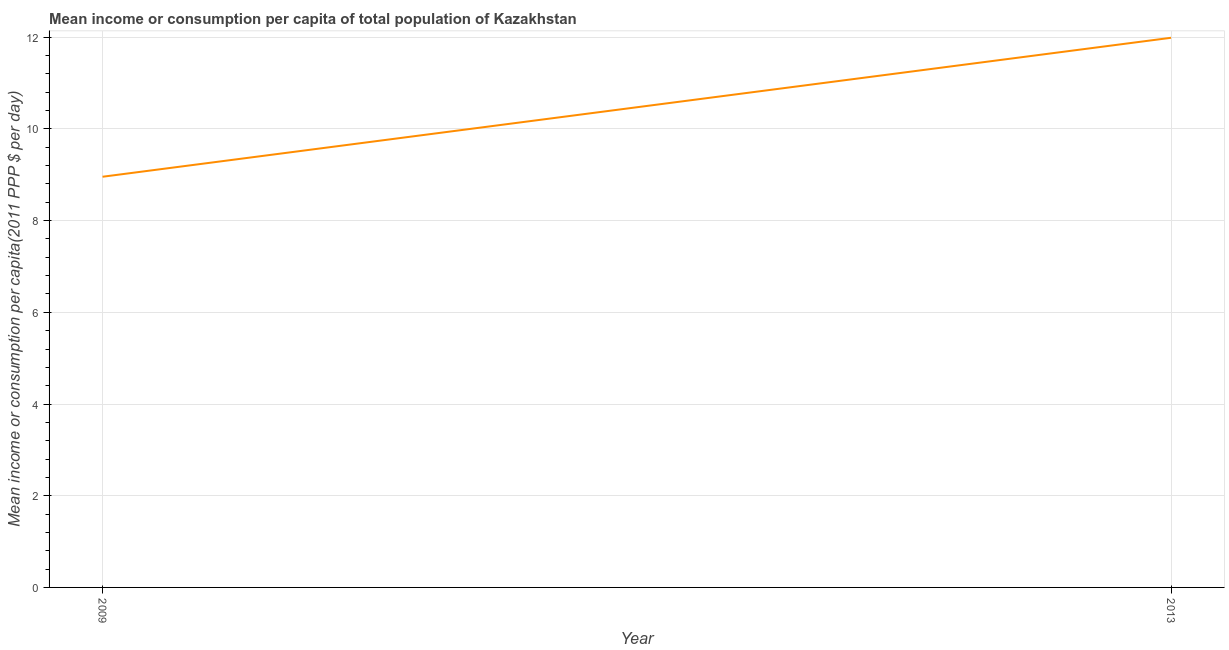What is the mean income or consumption in 2013?
Offer a terse response. 11.99. Across all years, what is the maximum mean income or consumption?
Provide a short and direct response. 11.99. Across all years, what is the minimum mean income or consumption?
Keep it short and to the point. 8.96. In which year was the mean income or consumption maximum?
Give a very brief answer. 2013. In which year was the mean income or consumption minimum?
Keep it short and to the point. 2009. What is the sum of the mean income or consumption?
Ensure brevity in your answer.  20.94. What is the difference between the mean income or consumption in 2009 and 2013?
Keep it short and to the point. -3.03. What is the average mean income or consumption per year?
Your answer should be very brief. 10.47. What is the median mean income or consumption?
Ensure brevity in your answer.  10.47. In how many years, is the mean income or consumption greater than 8 $?
Keep it short and to the point. 2. Do a majority of the years between 2013 and 2009 (inclusive) have mean income or consumption greater than 10.8 $?
Your response must be concise. No. What is the ratio of the mean income or consumption in 2009 to that in 2013?
Give a very brief answer. 0.75. In how many years, is the mean income or consumption greater than the average mean income or consumption taken over all years?
Offer a terse response. 1. Does the mean income or consumption monotonically increase over the years?
Your answer should be compact. Yes. Are the values on the major ticks of Y-axis written in scientific E-notation?
Provide a succinct answer. No. Does the graph contain grids?
Give a very brief answer. Yes. What is the title of the graph?
Give a very brief answer. Mean income or consumption per capita of total population of Kazakhstan. What is the label or title of the X-axis?
Provide a succinct answer. Year. What is the label or title of the Y-axis?
Provide a succinct answer. Mean income or consumption per capita(2011 PPP $ per day). What is the Mean income or consumption per capita(2011 PPP $ per day) in 2009?
Your response must be concise. 8.96. What is the Mean income or consumption per capita(2011 PPP $ per day) in 2013?
Keep it short and to the point. 11.99. What is the difference between the Mean income or consumption per capita(2011 PPP $ per day) in 2009 and 2013?
Give a very brief answer. -3.03. What is the ratio of the Mean income or consumption per capita(2011 PPP $ per day) in 2009 to that in 2013?
Ensure brevity in your answer.  0.75. 